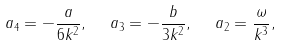Convert formula to latex. <formula><loc_0><loc_0><loc_500><loc_500>a _ { 4 } = - \frac { a } { 6 k ^ { 2 } } , \ \ a _ { 3 } = - \frac { b } { 3 k ^ { 2 } } , \ \ a _ { 2 } = \frac { \omega } { k ^ { 3 } } ,</formula> 